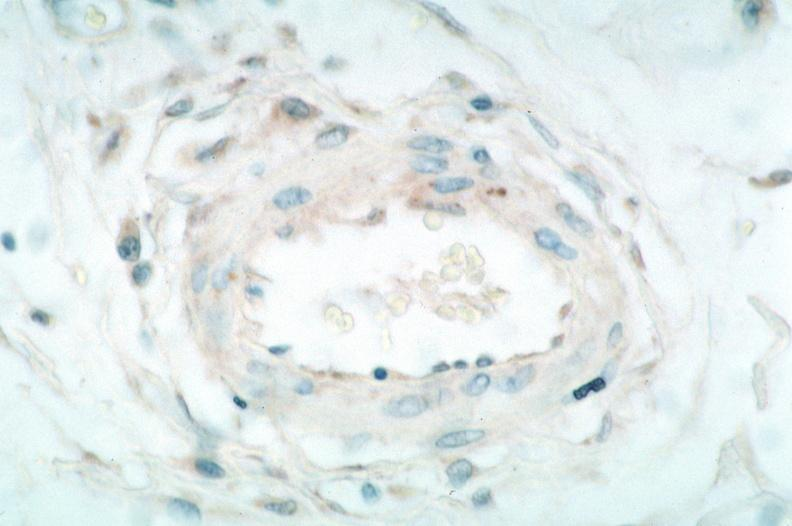what spotted fever , immunoperoxidase staining vessels for rickettsia rickettsii?
Answer the question using a single word or phrase. Vasculitis rocky mountain 